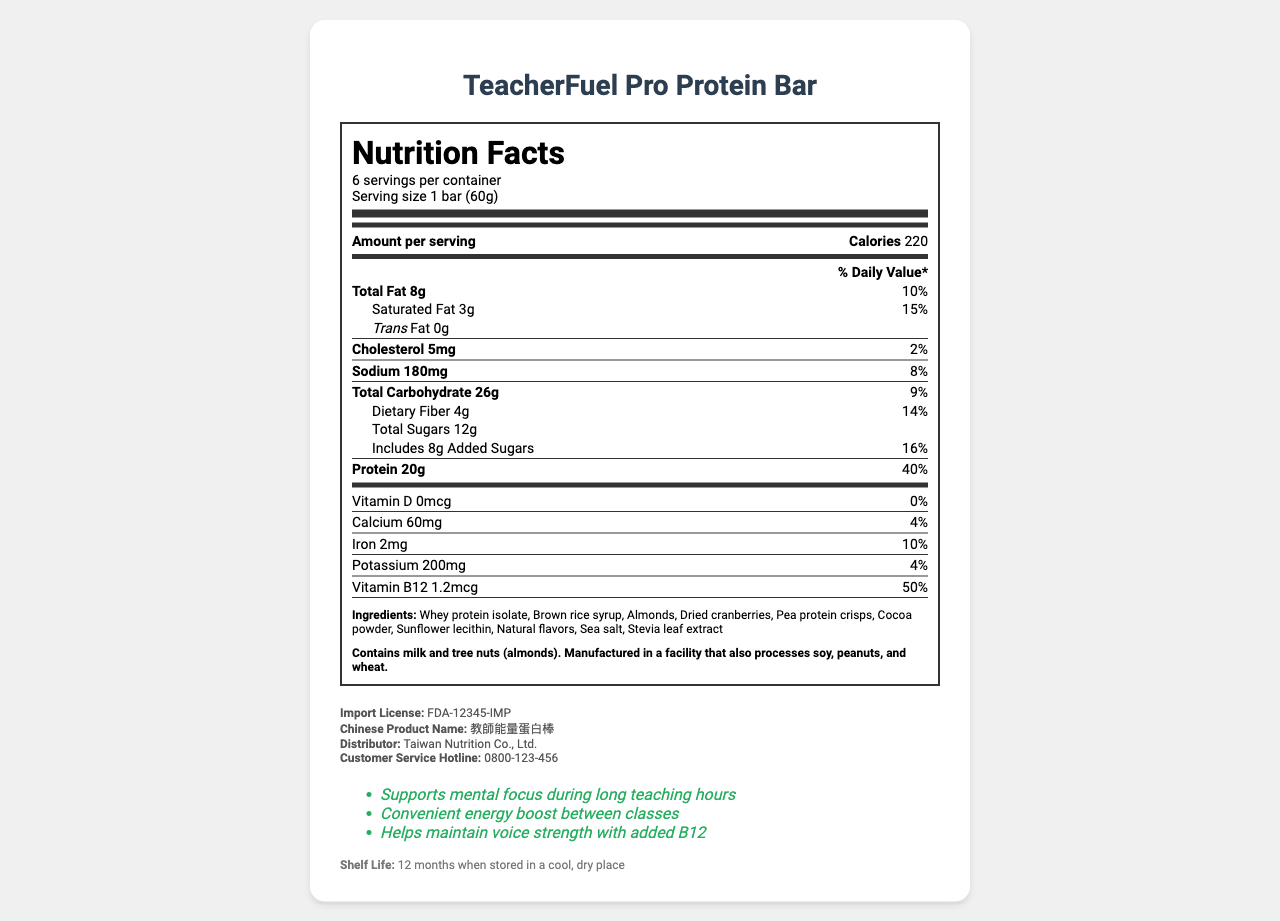what is the serving size of the TeacherFuel Pro Protein Bar? The serving size is explicitly mentioned in the document as "1 bar (60g)".
Answer: 1 bar (60g) how many servings are there per container? The document states that there are 6 servings per container.
Answer: 6 what is the amount of protein per serving? According to the document, one serving contains 20g of protein.
Answer: 20g how much total fat is in one serving of the protein bar? The total fat per serving is listed as 8g in the document.
Answer: 8g what is the daily value percentage of Vitamin B12 in one serving of the bar? The document indicates that one serving provides 50% of the daily value for Vitamin B12.
Answer: 50% how much added sugar is in each serving? The document states that each serving contains 8g of added sugars.
Answer: 8g what is the sodium content per serving? The sodium content per serving is listed as 180mg in the document.
Answer: 180mg how many calories are there per serving? The document shows that each serving contains 220 calories.
Answer: 220 does the bar contain any trans fat? The document states the trans fat content as 0g, meaning there is no trans fat in the bar.
Answer: No which of the following ingredients are included in the TeacherFuel Pro Protein Bar? A. Whey protein isolate B. Stevia leaf extract C. Sea salt D. All of the above All listed ingredients (Whey protein isolate, Stevia leaf extract, and Sea salt) are part of the ingredients according to the document.
Answer: D which allergen is present in the protein bar? A. Gluten B. Tree nuts C. Soy The document mentions that the bar contains tree nuts (almonds).
Answer: B what is the shelf life of the TeacherFuel Pro Protein Bar? The document specifies that the shelf life is 12 months when stored properly.
Answer: 12 months when stored in a cool, dry place does this bar contain any cholesterol? The document states that one serving contains 5mg of cholesterol.
Answer: Yes describe the purpose and benefits of the TeacherFuel Pro Protein Bar as mentioned in the document. The document lists these claims under the "teacher-targeted claims" section, offering specific benefits tailored for English educators.
Answer: The TeacherFuel Pro Protein Bar is designed to support mental focus during long teaching hours, provide a convenient energy boost between classes, and help maintain voice strength with added B12. is this product suitable for someone with a soy allergy? The document notes that the bar is manufactured in a facility that processes soy, making it potentially unsafe for someone with a soy allergy.
Answer: Not advisable where can you find the Customer Service Hotline for further inquiries about the product in Taiwan? The document includes the customer service hotline in the Taiwan-specific information section.
Answer: 0800-123-456 who is the distributor of TeacherFuel Pro Protein Bar in Taiwan? This information is found in the Taiwan-specific information section of the document.
Answer: Taiwan Nutrition Co., Ltd. what is the Chinese product name for TeacherFuel Pro Protein Bar? The Chinese product name is listed in the Taiwan-specific information.
Answer: 教師能量蛋白棒 which vitamin is not present in the TeacherFuel Pro Protein Bar? The document states that the amount of Vitamin D is 0mcg, indicating it's not present in the bar.
Answer: Vitamin D how much dietary fiber is in each serving, and what is its daily value percentage? Each serving contains 4g of dietary fiber, which is 14% of the daily value.
Answer: 4g, 14% 